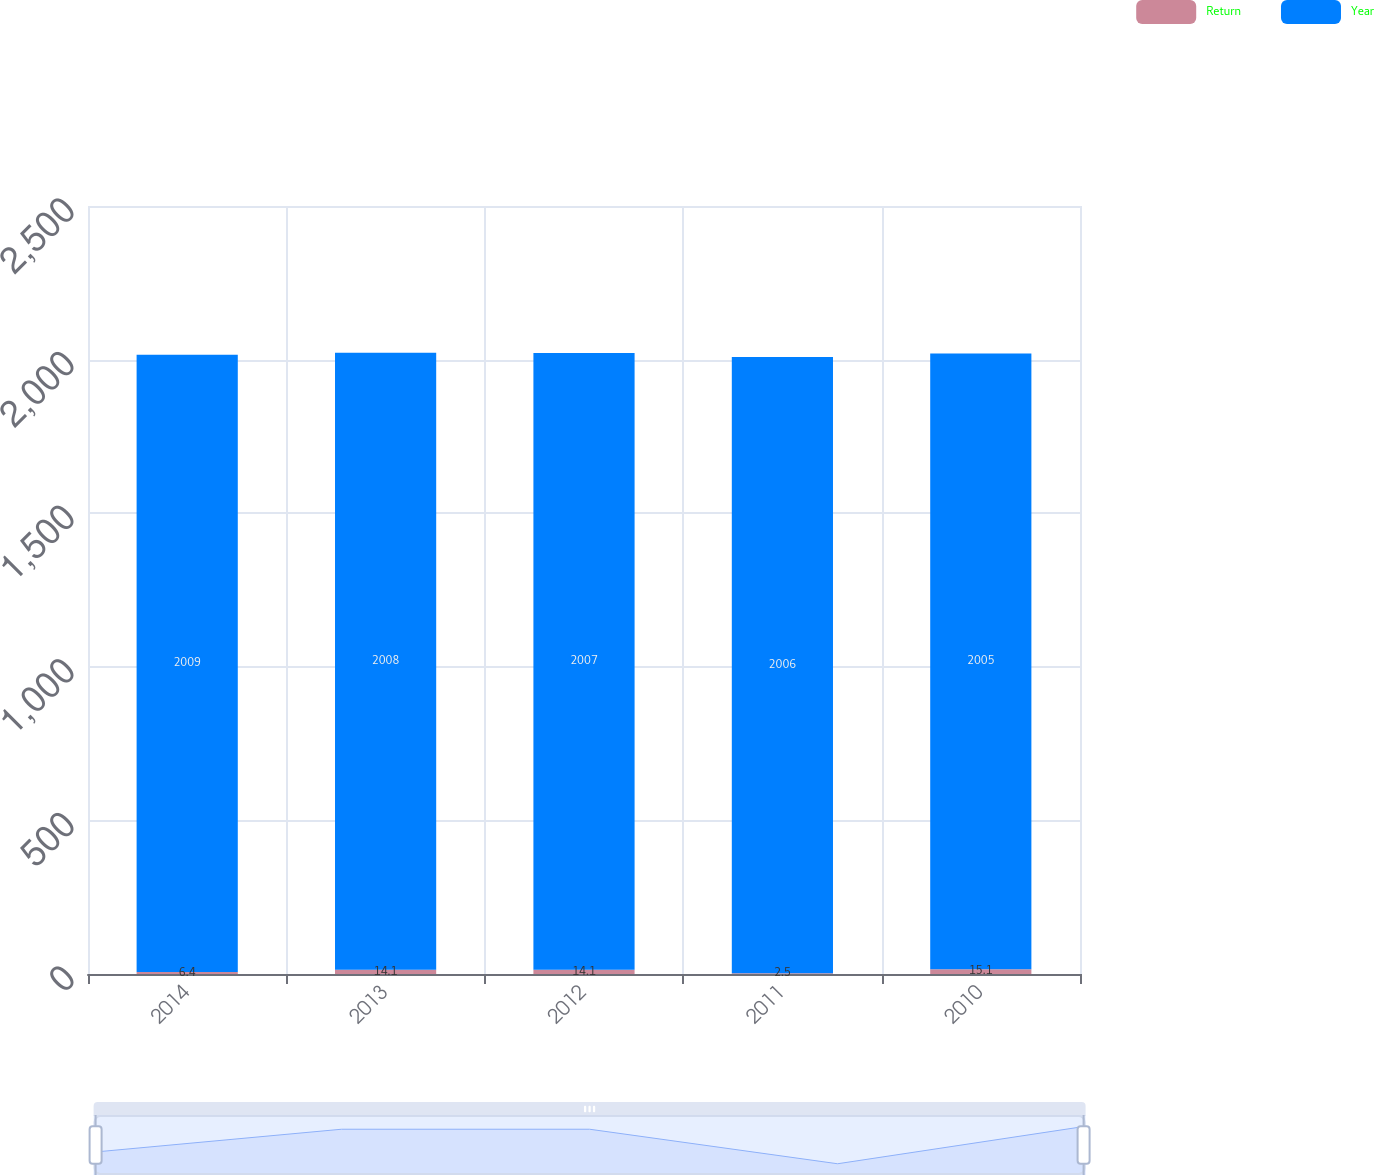Convert chart to OTSL. <chart><loc_0><loc_0><loc_500><loc_500><stacked_bar_chart><ecel><fcel>2014<fcel>2013<fcel>2012<fcel>2011<fcel>2010<nl><fcel>Return<fcel>6.4<fcel>14.1<fcel>14.1<fcel>2.5<fcel>15.1<nl><fcel>Year<fcel>2009<fcel>2008<fcel>2007<fcel>2006<fcel>2005<nl></chart> 